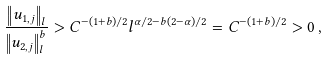Convert formula to latex. <formula><loc_0><loc_0><loc_500><loc_500>\frac { \left \| u _ { 1 , j } \right \| _ { l } } { \left \| u _ { 2 , j } \right \| _ { l } ^ { b } } > C ^ { - ( 1 + b ) / 2 } l ^ { \alpha / 2 - b ( 2 - \alpha ) / 2 } = C ^ { - ( 1 + b ) / 2 } > 0 \, ,</formula> 